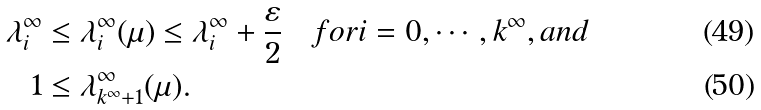<formula> <loc_0><loc_0><loc_500><loc_500>\lambda ^ { \infty } _ { i } & \leq \lambda ^ { \infty } _ { i } ( \mu ) \leq \lambda ^ { \infty } _ { i } + \frac { \varepsilon } { 2 } \quad f o r i = 0 , \cdots , k ^ { \infty } , a n d \\ 1 & \leq \lambda ^ { \infty } _ { k ^ { \infty } + 1 } ( \mu ) .</formula> 